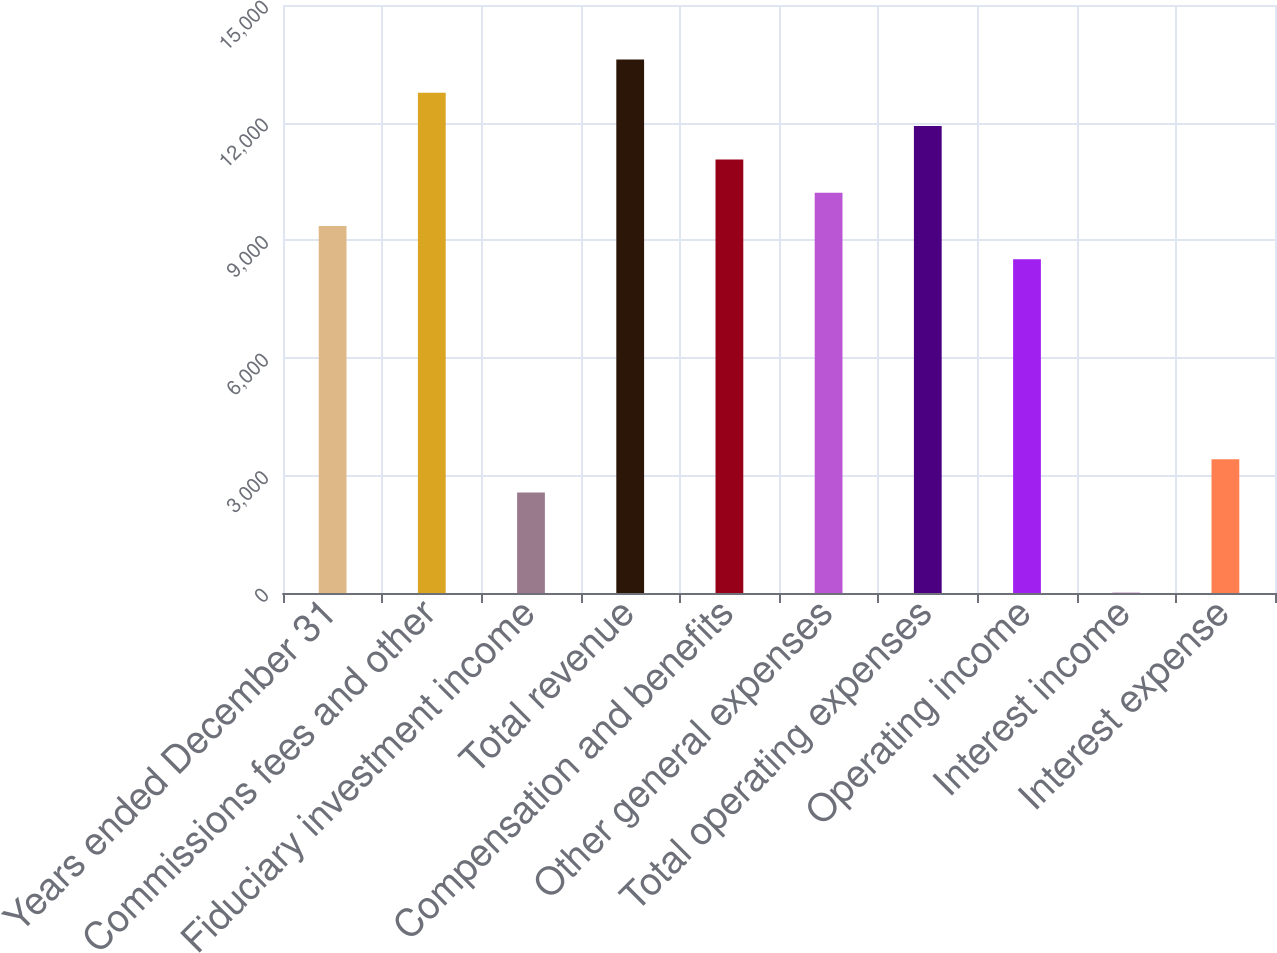Convert chart to OTSL. <chart><loc_0><loc_0><loc_500><loc_500><bar_chart><fcel>Years ended December 31<fcel>Commissions fees and other<fcel>Fiduciary investment income<fcel>Total revenue<fcel>Compensation and benefits<fcel>Other general expenses<fcel>Total operating expenses<fcel>Operating income<fcel>Interest income<fcel>Interest expense<nl><fcel>9361.7<fcel>12760.5<fcel>2564.1<fcel>13610.2<fcel>11061.1<fcel>10211.4<fcel>11910.8<fcel>8512<fcel>15<fcel>3413.8<nl></chart> 